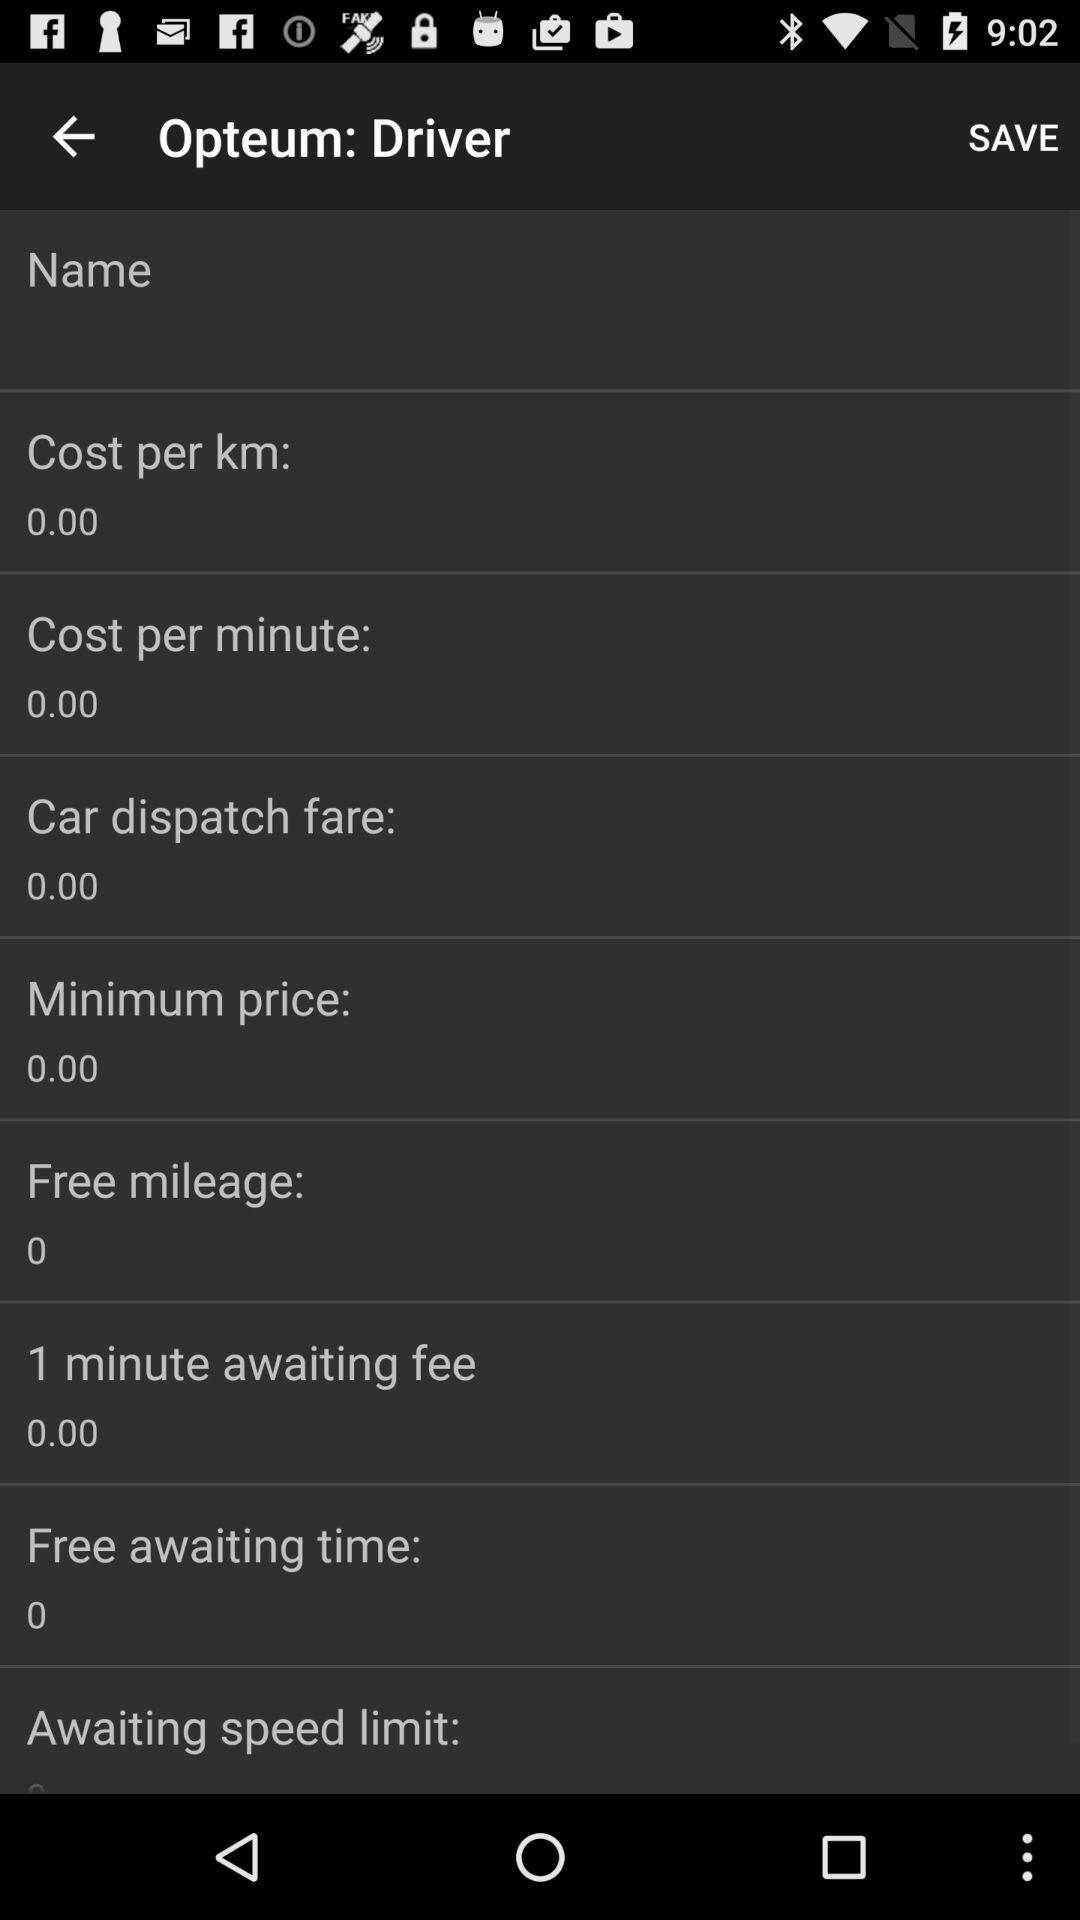What is the cost per minute? The cost per minute is 0. 